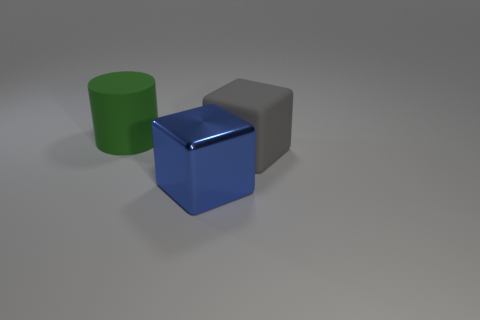Add 1 large yellow matte cylinders. How many objects exist? 4 Subtract all cubes. How many objects are left? 1 Add 1 gray metal blocks. How many gray metal blocks exist? 1 Subtract 0 cyan cylinders. How many objects are left? 3 Subtract all small gray metal balls. Subtract all cubes. How many objects are left? 1 Add 3 big matte cubes. How many big matte cubes are left? 4 